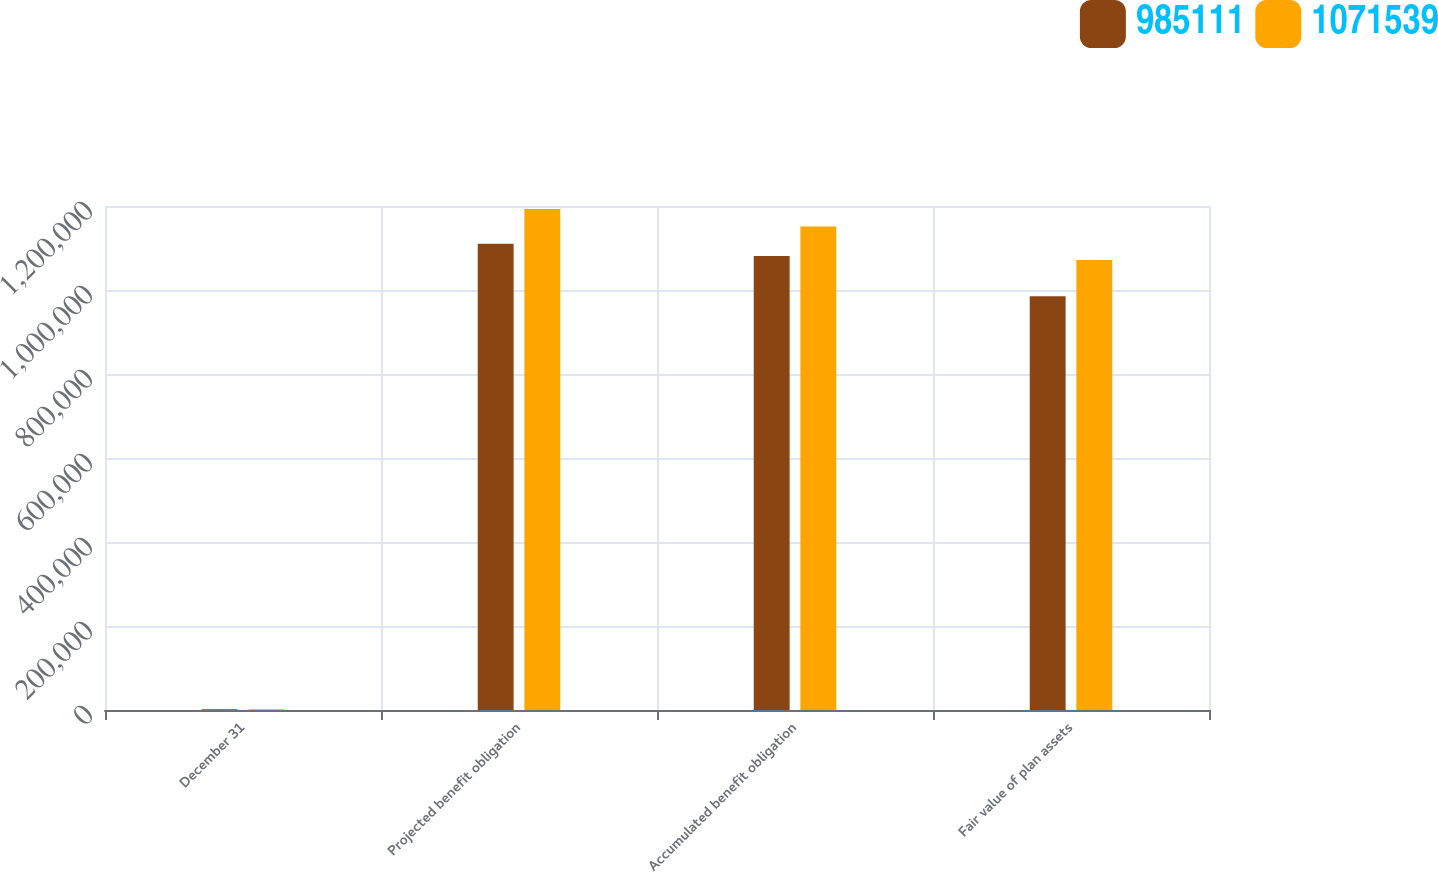<chart> <loc_0><loc_0><loc_500><loc_500><stacked_bar_chart><ecel><fcel>December 31<fcel>Projected benefit obligation<fcel>Accumulated benefit obligation<fcel>Fair value of plan assets<nl><fcel>985111<fcel>2015<fcel>1.11023e+06<fcel>1.081e+06<fcel>985111<nl><fcel>1.07154e+06<fcel>2014<fcel>1.19315e+06<fcel>1.15121e+06<fcel>1.07154e+06<nl></chart> 